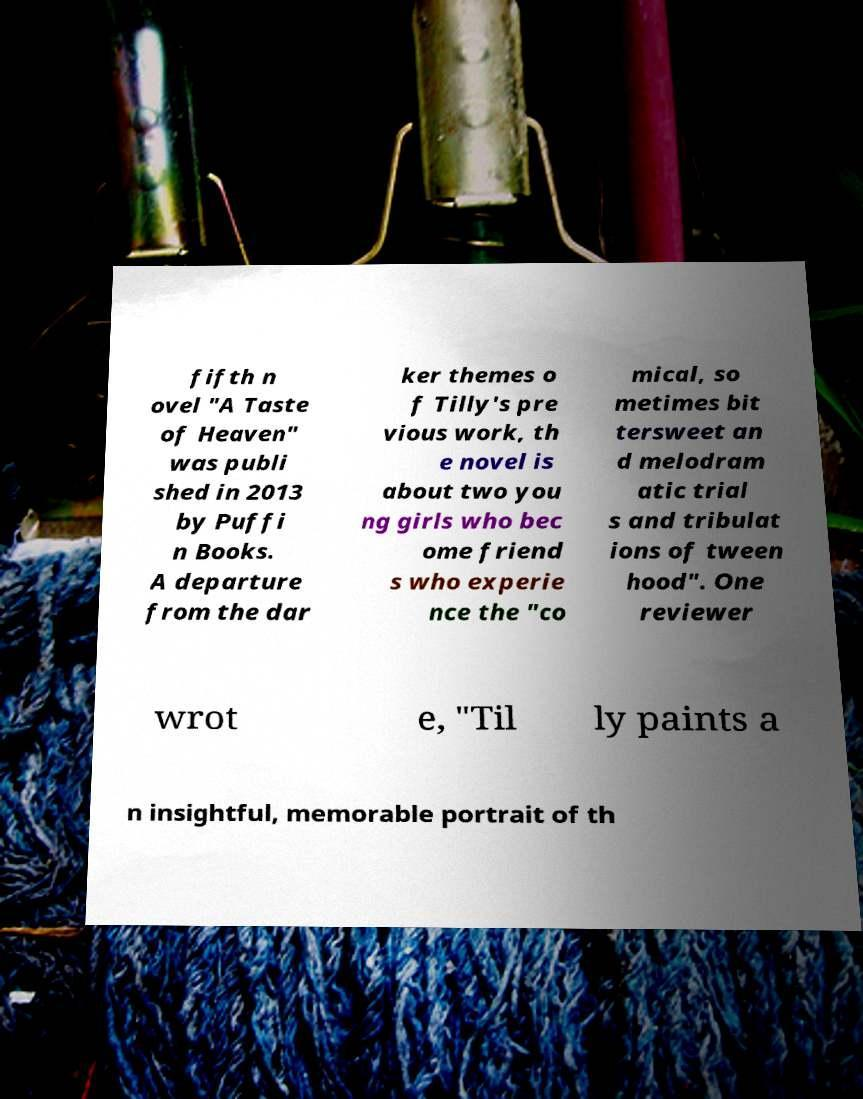Could you assist in decoding the text presented in this image and type it out clearly? fifth n ovel "A Taste of Heaven" was publi shed in 2013 by Puffi n Books. A departure from the dar ker themes o f Tilly's pre vious work, th e novel is about two you ng girls who bec ome friend s who experie nce the "co mical, so metimes bit tersweet an d melodram atic trial s and tribulat ions of tween hood". One reviewer wrot e, "Til ly paints a n insightful, memorable portrait of th 